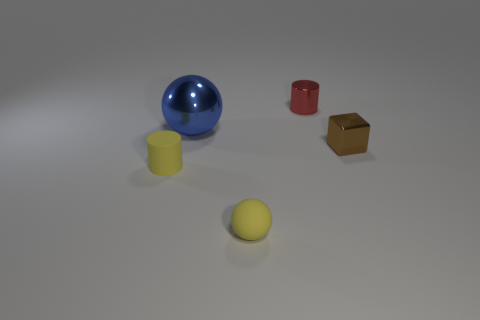Add 3 small yellow rubber balls. How many objects exist? 8 Subtract all cubes. How many objects are left? 4 Subtract 0 brown cylinders. How many objects are left? 5 Subtract all blue balls. Subtract all metal blocks. How many objects are left? 3 Add 4 brown metallic objects. How many brown metallic objects are left? 5 Add 5 small yellow balls. How many small yellow balls exist? 6 